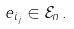<formula> <loc_0><loc_0><loc_500><loc_500>e _ { i _ { j } } \in \mathcal { E } _ { n } \, .</formula> 